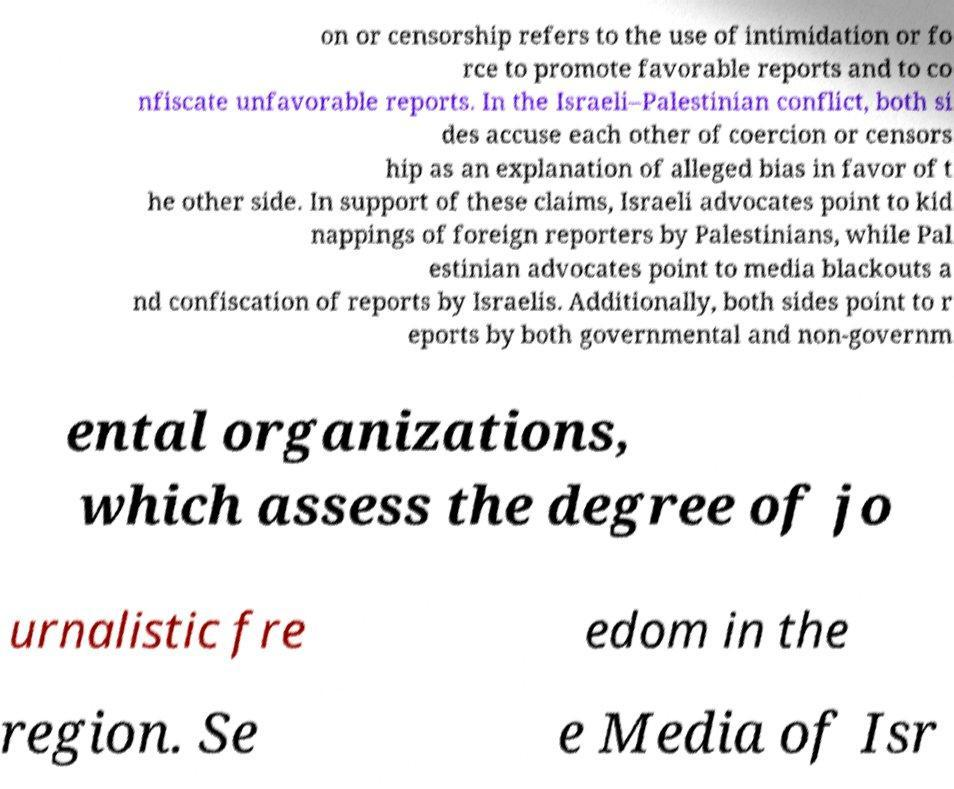I need the written content from this picture converted into text. Can you do that? on or censorship refers to the use of intimidation or fo rce to promote favorable reports and to co nfiscate unfavorable reports. In the Israeli–Palestinian conflict, both si des accuse each other of coercion or censors hip as an explanation of alleged bias in favor of t he other side. In support of these claims, Israeli advocates point to kid nappings of foreign reporters by Palestinians, while Pal estinian advocates point to media blackouts a nd confiscation of reports by Israelis. Additionally, both sides point to r eports by both governmental and non-governm ental organizations, which assess the degree of jo urnalistic fre edom in the region. Se e Media of Isr 